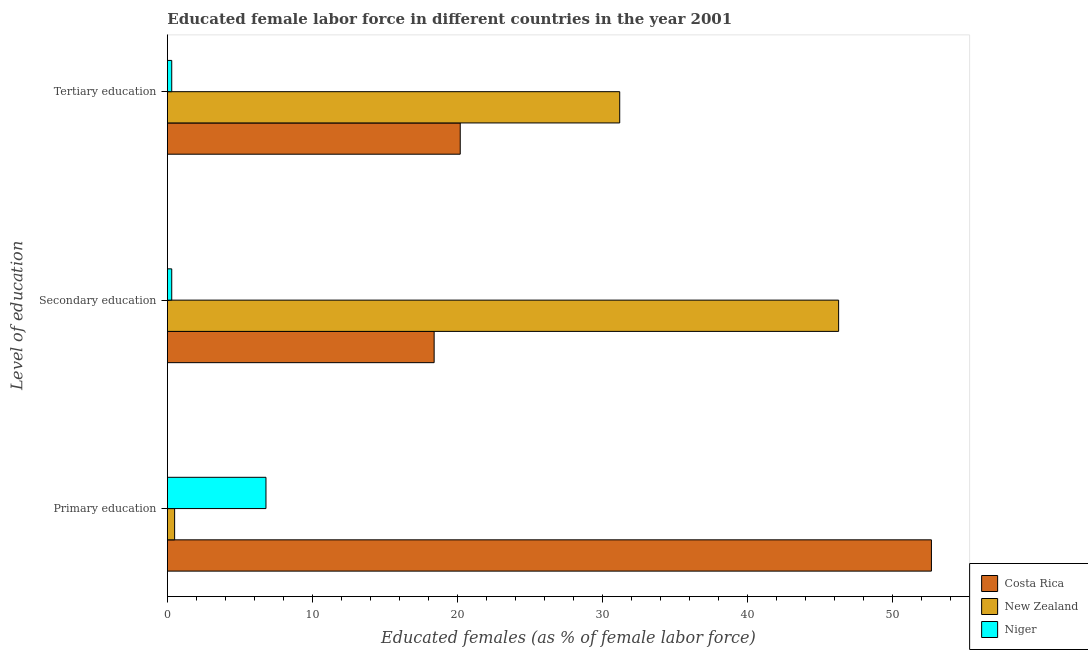How many different coloured bars are there?
Provide a short and direct response. 3. Are the number of bars per tick equal to the number of legend labels?
Your answer should be very brief. Yes. Are the number of bars on each tick of the Y-axis equal?
Offer a very short reply. Yes. How many bars are there on the 3rd tick from the top?
Your answer should be compact. 3. What is the label of the 1st group of bars from the top?
Provide a succinct answer. Tertiary education. What is the percentage of female labor force who received tertiary education in Niger?
Provide a succinct answer. 0.3. Across all countries, what is the maximum percentage of female labor force who received primary education?
Provide a short and direct response. 52.7. Across all countries, what is the minimum percentage of female labor force who received tertiary education?
Provide a short and direct response. 0.3. In which country was the percentage of female labor force who received secondary education maximum?
Give a very brief answer. New Zealand. In which country was the percentage of female labor force who received primary education minimum?
Your answer should be compact. New Zealand. What is the total percentage of female labor force who received primary education in the graph?
Provide a short and direct response. 60. What is the difference between the percentage of female labor force who received tertiary education in New Zealand and that in Costa Rica?
Your answer should be very brief. 11. What is the difference between the percentage of female labor force who received primary education in Costa Rica and the percentage of female labor force who received tertiary education in New Zealand?
Ensure brevity in your answer.  21.5. What is the average percentage of female labor force who received primary education per country?
Your answer should be compact. 20. What is the difference between the percentage of female labor force who received primary education and percentage of female labor force who received secondary education in Niger?
Give a very brief answer. 6.5. In how many countries, is the percentage of female labor force who received primary education greater than 2 %?
Make the answer very short. 2. What is the ratio of the percentage of female labor force who received tertiary education in Niger to that in Costa Rica?
Provide a short and direct response. 0.01. Is the percentage of female labor force who received primary education in Costa Rica less than that in Niger?
Provide a succinct answer. No. What is the difference between the highest and the second highest percentage of female labor force who received secondary education?
Your answer should be very brief. 27.9. What is the difference between the highest and the lowest percentage of female labor force who received secondary education?
Offer a very short reply. 46. What does the 2nd bar from the top in Tertiary education represents?
Your response must be concise. New Zealand. How many bars are there?
Make the answer very short. 9. How many countries are there in the graph?
Provide a short and direct response. 3. What is the difference between two consecutive major ticks on the X-axis?
Your answer should be compact. 10. Are the values on the major ticks of X-axis written in scientific E-notation?
Provide a succinct answer. No. Does the graph contain any zero values?
Make the answer very short. No. How are the legend labels stacked?
Keep it short and to the point. Vertical. What is the title of the graph?
Your answer should be very brief. Educated female labor force in different countries in the year 2001. Does "Japan" appear as one of the legend labels in the graph?
Give a very brief answer. No. What is the label or title of the X-axis?
Ensure brevity in your answer.  Educated females (as % of female labor force). What is the label or title of the Y-axis?
Offer a terse response. Level of education. What is the Educated females (as % of female labor force) of Costa Rica in Primary education?
Provide a short and direct response. 52.7. What is the Educated females (as % of female labor force) of New Zealand in Primary education?
Provide a short and direct response. 0.5. What is the Educated females (as % of female labor force) of Niger in Primary education?
Offer a very short reply. 6.8. What is the Educated females (as % of female labor force) in Costa Rica in Secondary education?
Offer a terse response. 18.4. What is the Educated females (as % of female labor force) of New Zealand in Secondary education?
Make the answer very short. 46.3. What is the Educated females (as % of female labor force) in Niger in Secondary education?
Provide a short and direct response. 0.3. What is the Educated females (as % of female labor force) of Costa Rica in Tertiary education?
Make the answer very short. 20.2. What is the Educated females (as % of female labor force) of New Zealand in Tertiary education?
Keep it short and to the point. 31.2. What is the Educated females (as % of female labor force) of Niger in Tertiary education?
Offer a very short reply. 0.3. Across all Level of education, what is the maximum Educated females (as % of female labor force) of Costa Rica?
Make the answer very short. 52.7. Across all Level of education, what is the maximum Educated females (as % of female labor force) of New Zealand?
Your answer should be compact. 46.3. Across all Level of education, what is the maximum Educated females (as % of female labor force) of Niger?
Provide a short and direct response. 6.8. Across all Level of education, what is the minimum Educated females (as % of female labor force) of Costa Rica?
Your answer should be very brief. 18.4. Across all Level of education, what is the minimum Educated females (as % of female labor force) in Niger?
Your response must be concise. 0.3. What is the total Educated females (as % of female labor force) in Costa Rica in the graph?
Ensure brevity in your answer.  91.3. What is the total Educated females (as % of female labor force) of Niger in the graph?
Offer a very short reply. 7.4. What is the difference between the Educated females (as % of female labor force) of Costa Rica in Primary education and that in Secondary education?
Offer a terse response. 34.3. What is the difference between the Educated females (as % of female labor force) in New Zealand in Primary education and that in Secondary education?
Offer a very short reply. -45.8. What is the difference between the Educated females (as % of female labor force) in Niger in Primary education and that in Secondary education?
Your response must be concise. 6.5. What is the difference between the Educated females (as % of female labor force) in Costa Rica in Primary education and that in Tertiary education?
Make the answer very short. 32.5. What is the difference between the Educated females (as % of female labor force) of New Zealand in Primary education and that in Tertiary education?
Your answer should be very brief. -30.7. What is the difference between the Educated females (as % of female labor force) of Costa Rica in Secondary education and that in Tertiary education?
Give a very brief answer. -1.8. What is the difference between the Educated females (as % of female labor force) in Niger in Secondary education and that in Tertiary education?
Your answer should be compact. 0. What is the difference between the Educated females (as % of female labor force) of Costa Rica in Primary education and the Educated females (as % of female labor force) of New Zealand in Secondary education?
Give a very brief answer. 6.4. What is the difference between the Educated females (as % of female labor force) in Costa Rica in Primary education and the Educated females (as % of female labor force) in Niger in Secondary education?
Your response must be concise. 52.4. What is the difference between the Educated females (as % of female labor force) of New Zealand in Primary education and the Educated females (as % of female labor force) of Niger in Secondary education?
Your response must be concise. 0.2. What is the difference between the Educated females (as % of female labor force) in Costa Rica in Primary education and the Educated females (as % of female labor force) in Niger in Tertiary education?
Give a very brief answer. 52.4. What is the difference between the Educated females (as % of female labor force) in New Zealand in Primary education and the Educated females (as % of female labor force) in Niger in Tertiary education?
Give a very brief answer. 0.2. What is the difference between the Educated females (as % of female labor force) in Costa Rica in Secondary education and the Educated females (as % of female labor force) in New Zealand in Tertiary education?
Your answer should be very brief. -12.8. What is the difference between the Educated females (as % of female labor force) in Costa Rica in Secondary education and the Educated females (as % of female labor force) in Niger in Tertiary education?
Keep it short and to the point. 18.1. What is the average Educated females (as % of female labor force) in Costa Rica per Level of education?
Provide a succinct answer. 30.43. What is the average Educated females (as % of female labor force) of Niger per Level of education?
Ensure brevity in your answer.  2.47. What is the difference between the Educated females (as % of female labor force) of Costa Rica and Educated females (as % of female labor force) of New Zealand in Primary education?
Offer a terse response. 52.2. What is the difference between the Educated females (as % of female labor force) of Costa Rica and Educated females (as % of female labor force) of Niger in Primary education?
Your response must be concise. 45.9. What is the difference between the Educated females (as % of female labor force) in New Zealand and Educated females (as % of female labor force) in Niger in Primary education?
Provide a succinct answer. -6.3. What is the difference between the Educated females (as % of female labor force) in Costa Rica and Educated females (as % of female labor force) in New Zealand in Secondary education?
Your response must be concise. -27.9. What is the difference between the Educated females (as % of female labor force) of Costa Rica and Educated females (as % of female labor force) of Niger in Secondary education?
Give a very brief answer. 18.1. What is the difference between the Educated females (as % of female labor force) in New Zealand and Educated females (as % of female labor force) in Niger in Secondary education?
Your response must be concise. 46. What is the difference between the Educated females (as % of female labor force) of Costa Rica and Educated females (as % of female labor force) of New Zealand in Tertiary education?
Make the answer very short. -11. What is the difference between the Educated females (as % of female labor force) in Costa Rica and Educated females (as % of female labor force) in Niger in Tertiary education?
Offer a terse response. 19.9. What is the difference between the Educated females (as % of female labor force) of New Zealand and Educated females (as % of female labor force) of Niger in Tertiary education?
Make the answer very short. 30.9. What is the ratio of the Educated females (as % of female labor force) of Costa Rica in Primary education to that in Secondary education?
Your answer should be compact. 2.86. What is the ratio of the Educated females (as % of female labor force) in New Zealand in Primary education to that in Secondary education?
Offer a terse response. 0.01. What is the ratio of the Educated females (as % of female labor force) in Niger in Primary education to that in Secondary education?
Your answer should be compact. 22.67. What is the ratio of the Educated females (as % of female labor force) of Costa Rica in Primary education to that in Tertiary education?
Offer a very short reply. 2.61. What is the ratio of the Educated females (as % of female labor force) of New Zealand in Primary education to that in Tertiary education?
Ensure brevity in your answer.  0.02. What is the ratio of the Educated females (as % of female labor force) of Niger in Primary education to that in Tertiary education?
Offer a very short reply. 22.67. What is the ratio of the Educated females (as % of female labor force) of Costa Rica in Secondary education to that in Tertiary education?
Ensure brevity in your answer.  0.91. What is the ratio of the Educated females (as % of female labor force) of New Zealand in Secondary education to that in Tertiary education?
Give a very brief answer. 1.48. What is the ratio of the Educated females (as % of female labor force) in Niger in Secondary education to that in Tertiary education?
Your answer should be very brief. 1. What is the difference between the highest and the second highest Educated females (as % of female labor force) of Costa Rica?
Make the answer very short. 32.5. What is the difference between the highest and the second highest Educated females (as % of female labor force) in Niger?
Keep it short and to the point. 6.5. What is the difference between the highest and the lowest Educated females (as % of female labor force) of Costa Rica?
Provide a short and direct response. 34.3. What is the difference between the highest and the lowest Educated females (as % of female labor force) in New Zealand?
Provide a short and direct response. 45.8. 